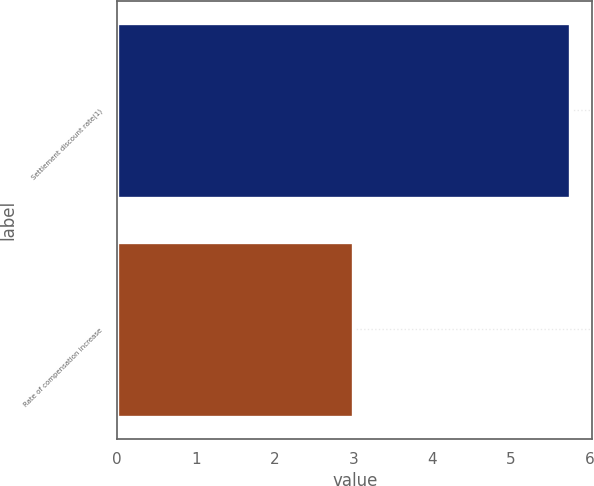<chart> <loc_0><loc_0><loc_500><loc_500><bar_chart><fcel>Settlement discount rate(1)<fcel>Rate of compensation increase<nl><fcel>5.75<fcel>3<nl></chart> 